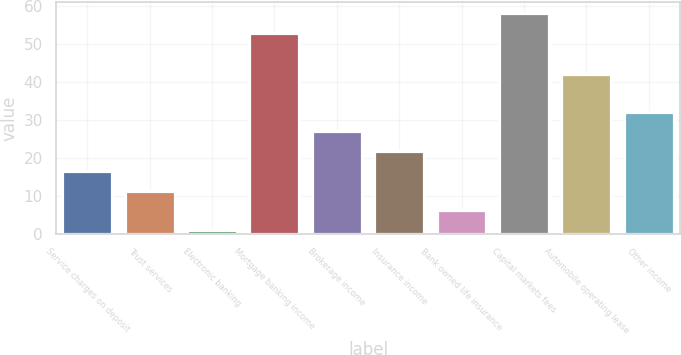<chart> <loc_0><loc_0><loc_500><loc_500><bar_chart><fcel>Service charges on deposit<fcel>Trust services<fcel>Electronic banking<fcel>Mortgage banking income<fcel>Brokerage income<fcel>Insurance income<fcel>Bank owned life insurance<fcel>Capital markets fees<fcel>Automobile operating lease<fcel>Other income<nl><fcel>16.6<fcel>11.4<fcel>1<fcel>53<fcel>27<fcel>21.8<fcel>6.2<fcel>58.2<fcel>42<fcel>32.2<nl></chart> 